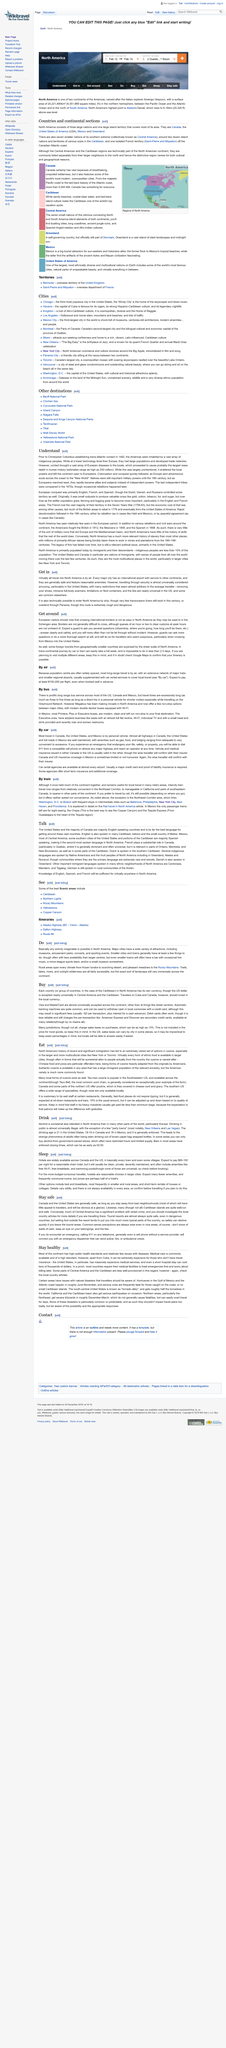Point out several critical features in this image. There are often queues at borders, with waits of up to an hour or two during peak hours being commonplace. European visitors may find it more challenging to navigate North America due to differences in border crossing procedures compared to the Schengen area. The use of the US dollar is nearly universally accepted in Central America and the Caribbean, a fact that is widely recognized and accepted by locals and visitors alike. The Northeast corridor train travel experience is explained in detail in a specific article, which focuses on the joy of rail travel in North America. It is estimated that the price per flight will range from $150 to $200. 